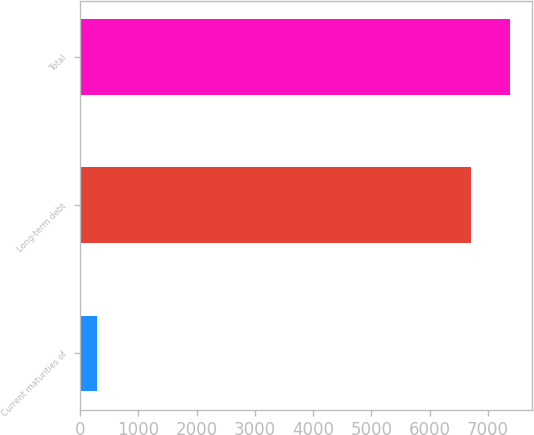Convert chart. <chart><loc_0><loc_0><loc_500><loc_500><bar_chart><fcel>Current maturities of<fcel>Long-term debt<fcel>Total<nl><fcel>289<fcel>6715<fcel>7386.5<nl></chart> 